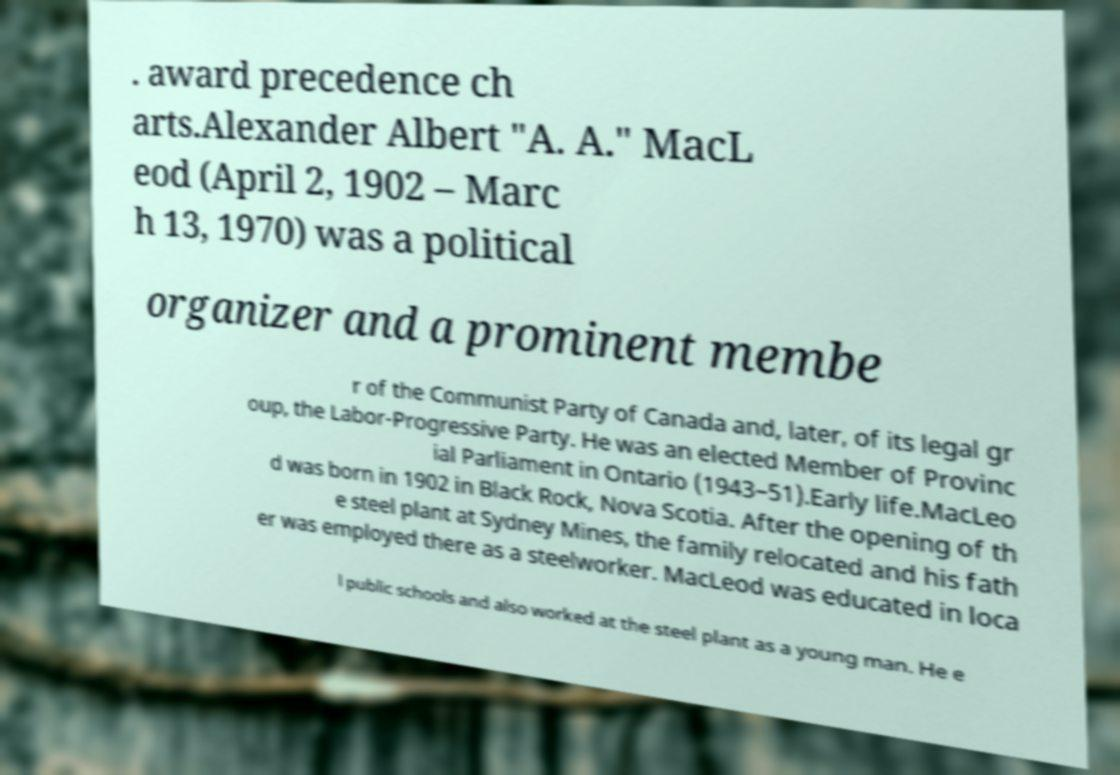Can you accurately transcribe the text from the provided image for me? . award precedence ch arts.Alexander Albert "A. A." MacL eod (April 2, 1902 – Marc h 13, 1970) was a political organizer and a prominent membe r of the Communist Party of Canada and, later, of its legal gr oup, the Labor-Progressive Party. He was an elected Member of Provinc ial Parliament in Ontario (1943–51).Early life.MacLeo d was born in 1902 in Black Rock, Nova Scotia. After the opening of th e steel plant at Sydney Mines, the family relocated and his fath er was employed there as a steelworker. MacLeod was educated in loca l public schools and also worked at the steel plant as a young man. He e 